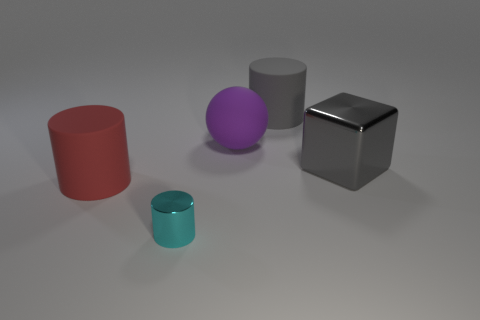Does the large ball have the same material as the tiny cyan object?
Keep it short and to the point. No. Are there any purple spheres made of the same material as the large red cylinder?
Make the answer very short. Yes. Is the number of gray metallic cubes less than the number of big rubber things?
Provide a short and direct response. Yes. Does the big cylinder behind the large gray metallic thing have the same color as the metal block?
Your answer should be compact. Yes. What material is the big cylinder on the right side of the big cylinder that is in front of the large rubber cylinder that is on the right side of the shiny cylinder?
Give a very brief answer. Rubber. Is there a large thing that has the same color as the block?
Offer a terse response. Yes. Are there fewer large matte objects to the right of the large gray rubber thing than tiny purple spheres?
Your response must be concise. No. There is a gray thing left of the metallic block; does it have the same size as the rubber ball?
Provide a short and direct response. Yes. What number of matte cylinders are on the right side of the big red cylinder and in front of the gray matte object?
Your answer should be compact. 0. What is the size of the cylinder behind the red matte thing in front of the big gray shiny block?
Your answer should be compact. Large. 